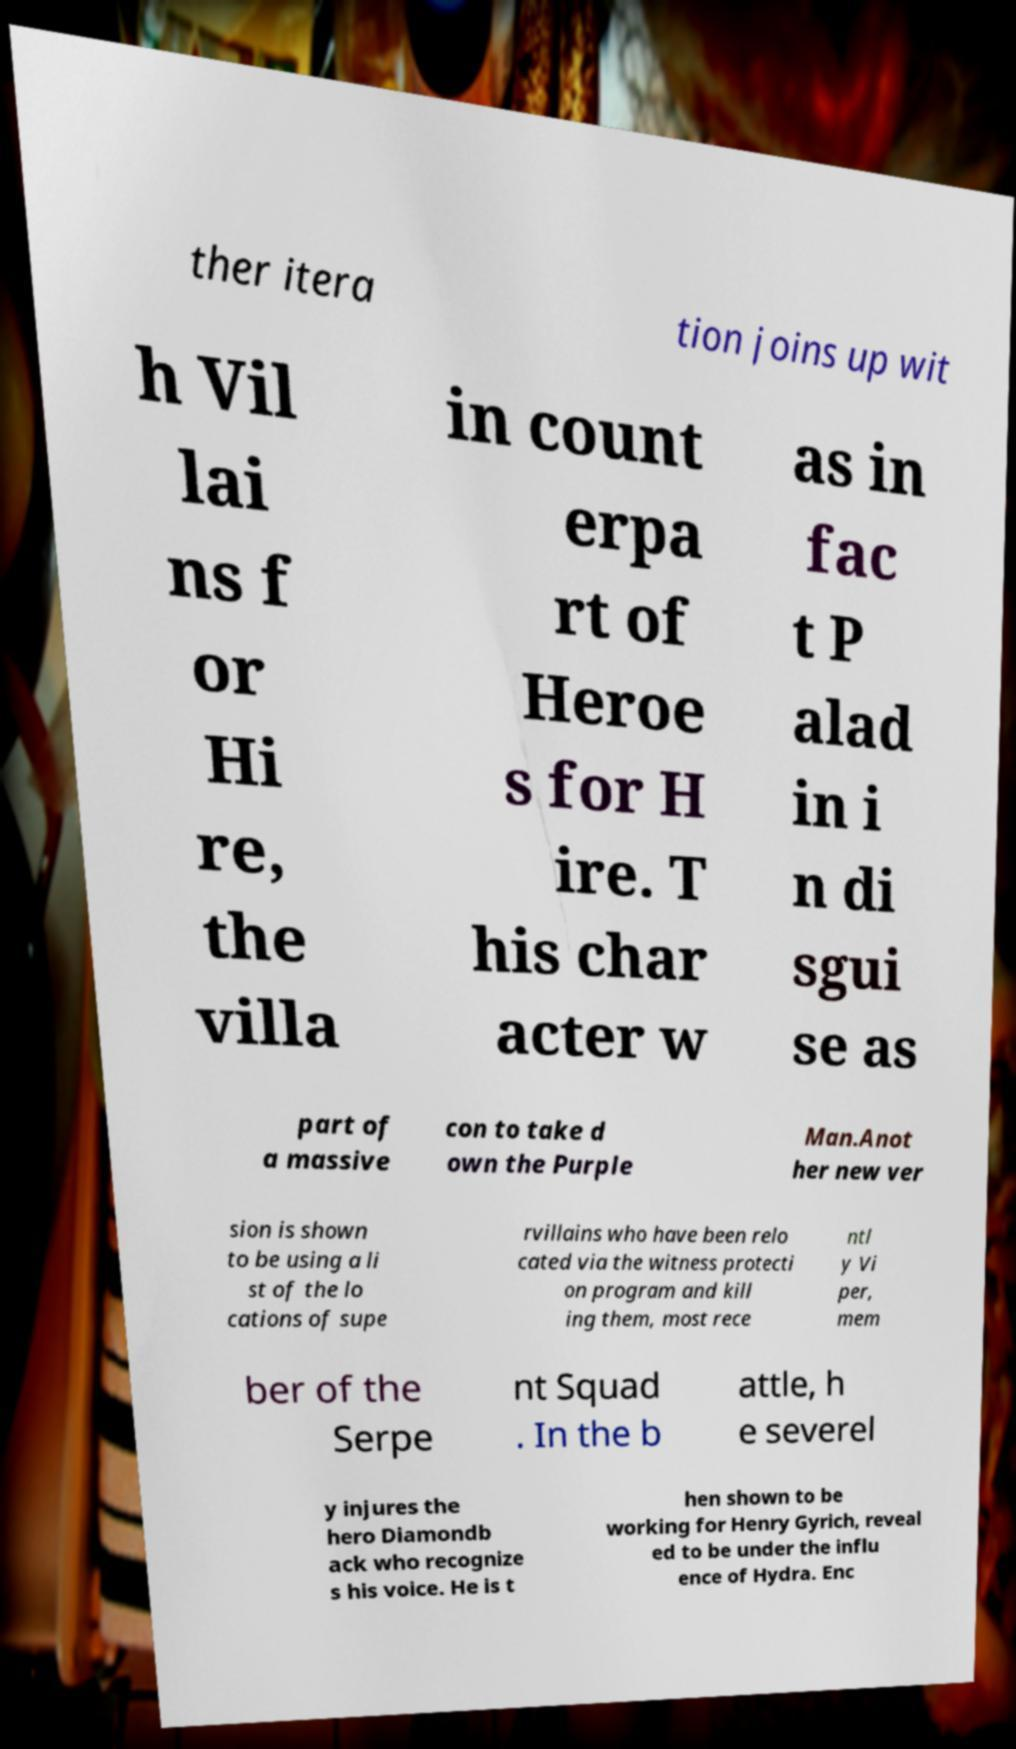Please identify and transcribe the text found in this image. ther itera tion joins up wit h Vil lai ns f or Hi re, the villa in count erpa rt of Heroe s for H ire. T his char acter w as in fac t P alad in i n di sgui se as part of a massive con to take d own the Purple Man.Anot her new ver sion is shown to be using a li st of the lo cations of supe rvillains who have been relo cated via the witness protecti on program and kill ing them, most rece ntl y Vi per, mem ber of the Serpe nt Squad . In the b attle, h e severel y injures the hero Diamondb ack who recognize s his voice. He is t hen shown to be working for Henry Gyrich, reveal ed to be under the influ ence of Hydra. Enc 